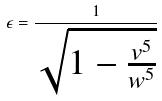Convert formula to latex. <formula><loc_0><loc_0><loc_500><loc_500>\epsilon = \frac { 1 } { \sqrt { 1 - \frac { v ^ { 5 } } { w ^ { 5 } } } }</formula> 